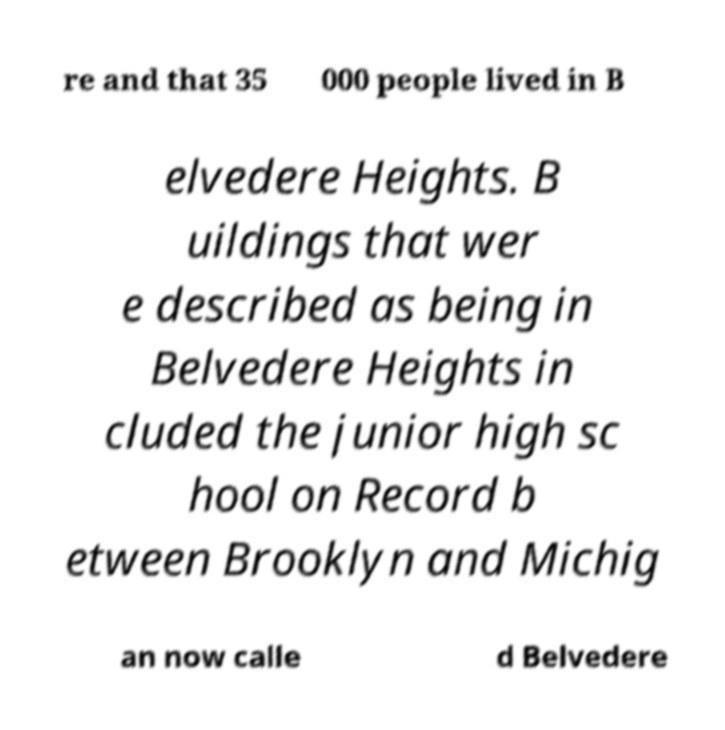There's text embedded in this image that I need extracted. Can you transcribe it verbatim? re and that 35 000 people lived in B elvedere Heights. B uildings that wer e described as being in Belvedere Heights in cluded the junior high sc hool on Record b etween Brooklyn and Michig an now calle d Belvedere 